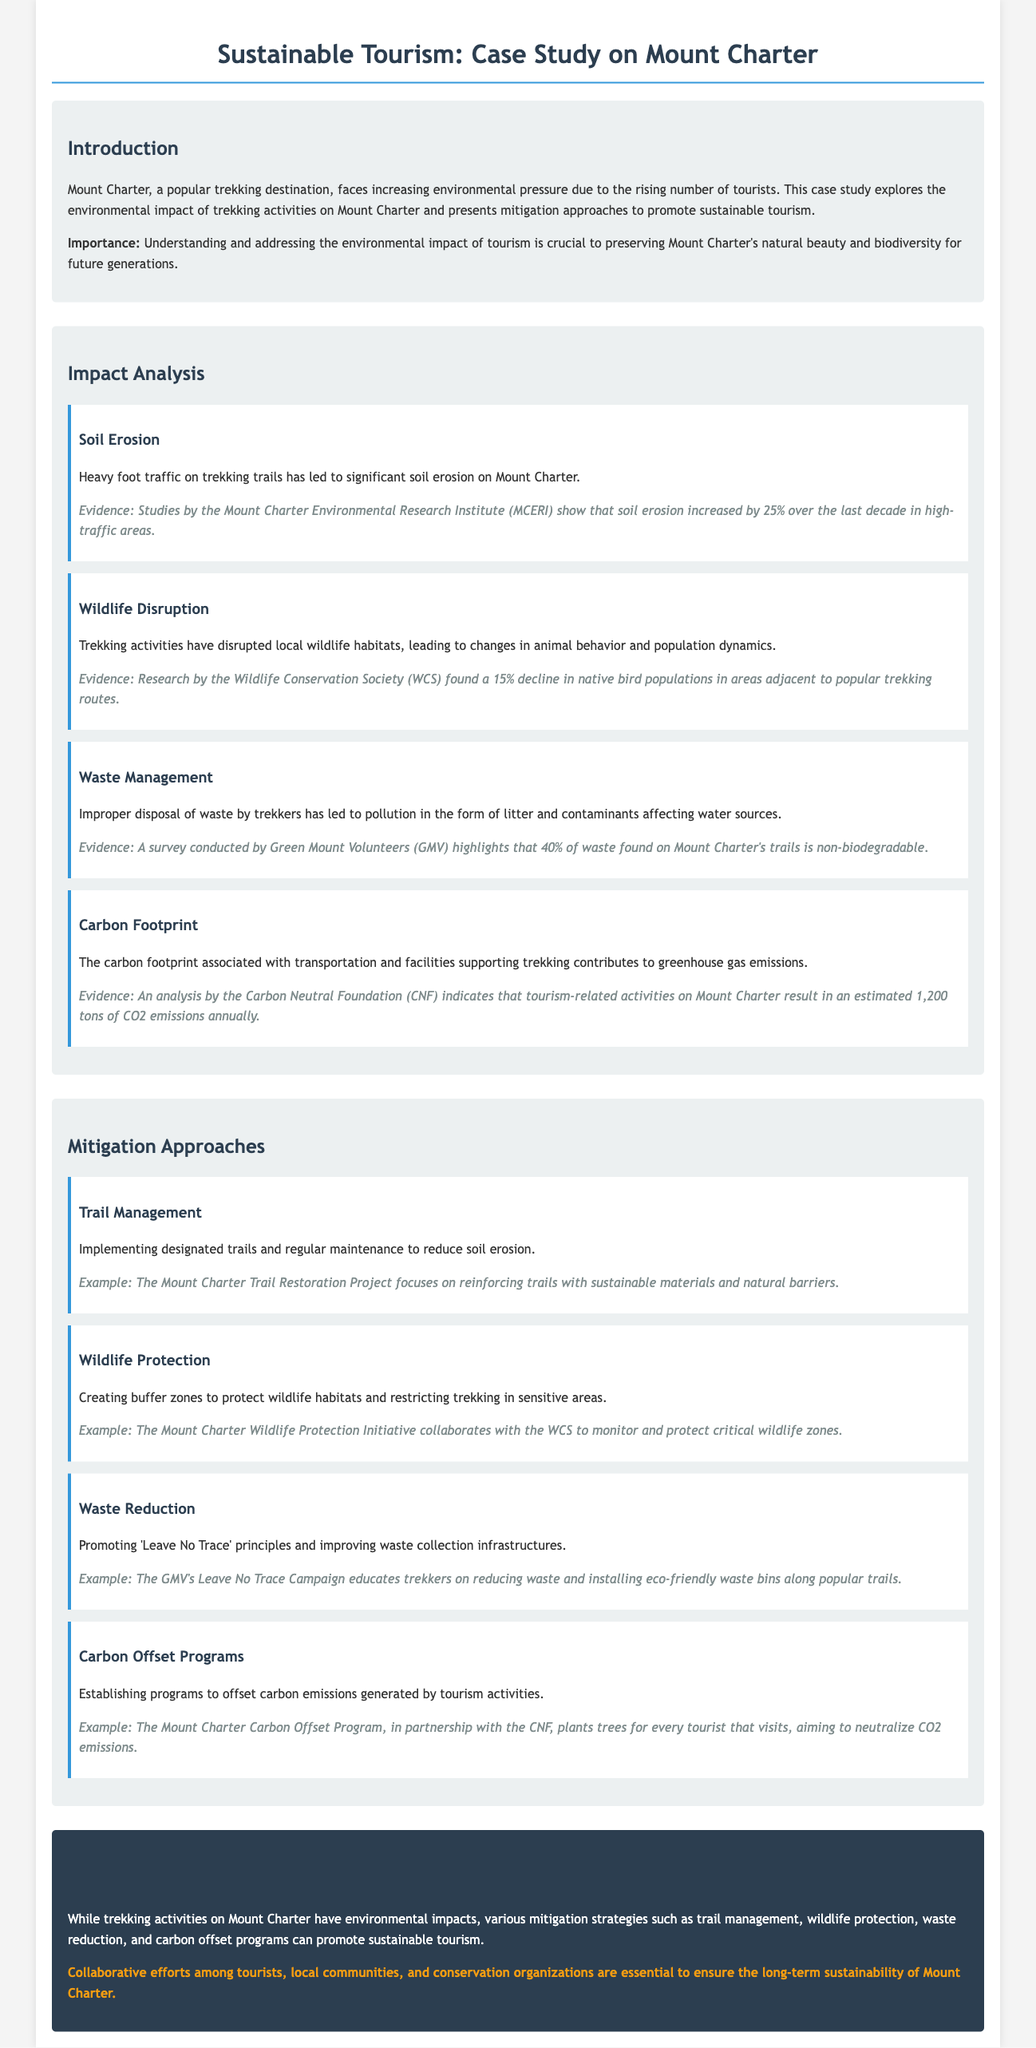What is the approximate increase in soil erosion over the last decade? The document states that soil erosion increased by 25% over the last decade in high-traffic areas.
Answer: 25% What organization conducted research on wildlife disruption? The Wildlife Conservation Society (WCS) is mentioned as the organization that found a decline in native bird populations.
Answer: WCS What percentage of waste found on Mount Charter's trails is non-biodegradable? The document highlights that 40% of waste found on the trails is non-biodegradable.
Answer: 40% What is one example of a mitigation approach mentioned in the document? The document provides various examples; one is the Mount Charter Trail Restoration Project.
Answer: Mount Charter Trail Restoration Project What type of carbon management approach does the Mount Charter Carbon Offset Program implement? The program aims to offset carbon emissions by planting trees for every tourist that visits.
Answer: Planting trees What impact does heavy foot traffic have on Mount Charter? Heavy foot traffic leads to significant soil erosion and other environmental issues according to the impact analysis.
Answer: Soil erosion Which initiative collaborates with the WCS for wildlife protection? The Mount Charter Wildlife Protection Initiative is mentioned as the initiative collaborating with WCS.
Answer: Mount Charter Wildlife Protection Initiative What is the main call to action from the conclusion? The call to action stresses the importance of collaborative efforts for the sustainability of Mount Charter.
Answer: Collaborative efforts What does the document advocate for regarding waste management? The document promotes 'Leave No Trace' principles as part of waste management strategies.
Answer: 'Leave No Trace' principles 